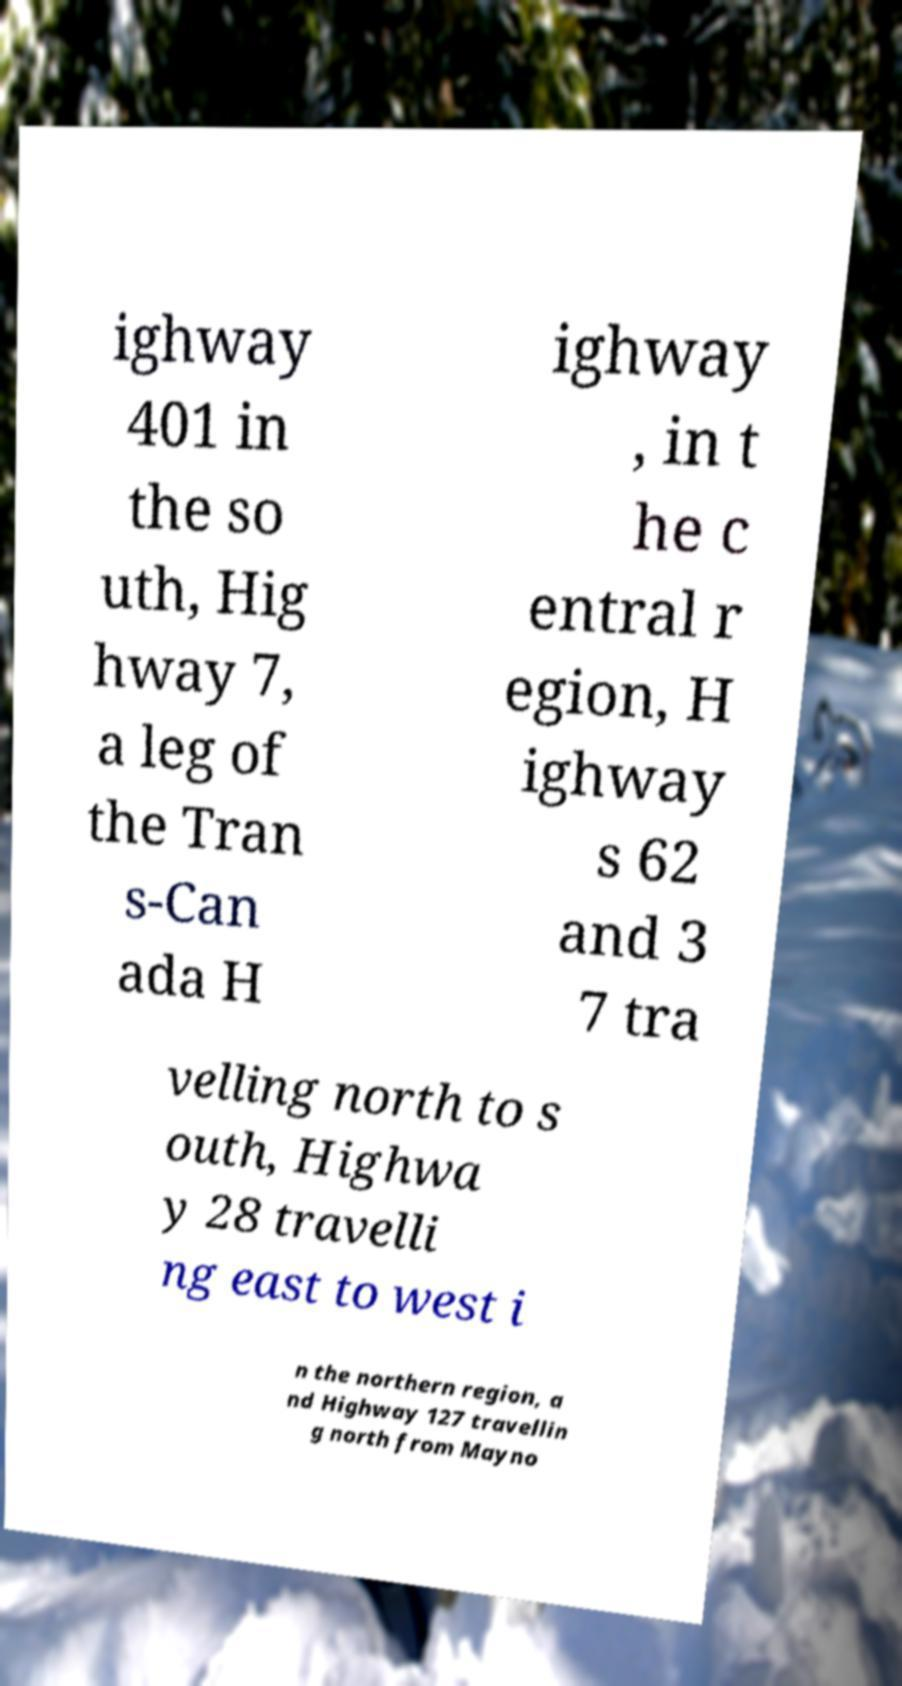Could you assist in decoding the text presented in this image and type it out clearly? ighway 401 in the so uth, Hig hway 7, a leg of the Tran s-Can ada H ighway , in t he c entral r egion, H ighway s 62 and 3 7 tra velling north to s outh, Highwa y 28 travelli ng east to west i n the northern region, a nd Highway 127 travellin g north from Mayno 